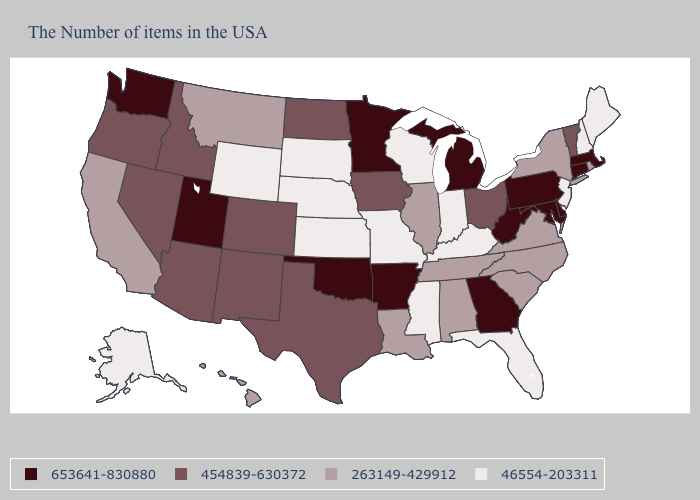Which states have the lowest value in the Northeast?
Short answer required. Maine, New Hampshire, New Jersey. Does Massachusetts have the highest value in the USA?
Quick response, please. Yes. Among the states that border Colorado , which have the lowest value?
Give a very brief answer. Kansas, Nebraska, Wyoming. What is the value of Alabama?
Be succinct. 263149-429912. What is the value of Washington?
Be succinct. 653641-830880. What is the value of Alaska?
Quick response, please. 46554-203311. What is the value of West Virginia?
Concise answer only. 653641-830880. How many symbols are there in the legend?
Short answer required. 4. Does Nebraska have a lower value than Wisconsin?
Be succinct. No. How many symbols are there in the legend?
Answer briefly. 4. What is the highest value in the West ?
Quick response, please. 653641-830880. Does New York have the lowest value in the Northeast?
Give a very brief answer. No. Which states have the lowest value in the West?
Give a very brief answer. Wyoming, Alaska. Name the states that have a value in the range 653641-830880?
Keep it brief. Massachusetts, Connecticut, Delaware, Maryland, Pennsylvania, West Virginia, Georgia, Michigan, Arkansas, Minnesota, Oklahoma, Utah, Washington. What is the value of Maryland?
Concise answer only. 653641-830880. 